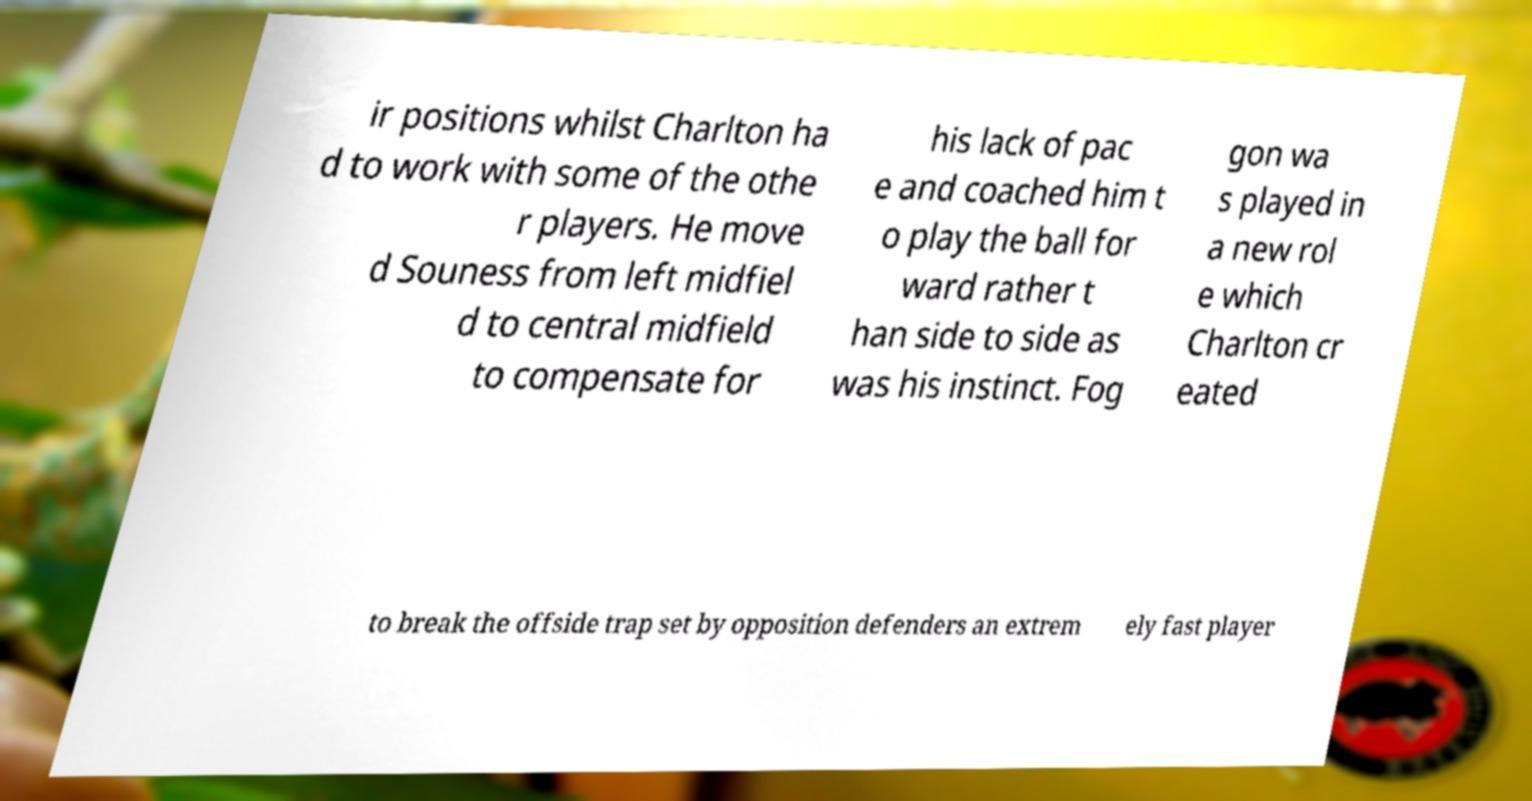Please identify and transcribe the text found in this image. ir positions whilst Charlton ha d to work with some of the othe r players. He move d Souness from left midfiel d to central midfield to compensate for his lack of pac e and coached him t o play the ball for ward rather t han side to side as was his instinct. Fog gon wa s played in a new rol e which Charlton cr eated to break the offside trap set by opposition defenders an extrem ely fast player 